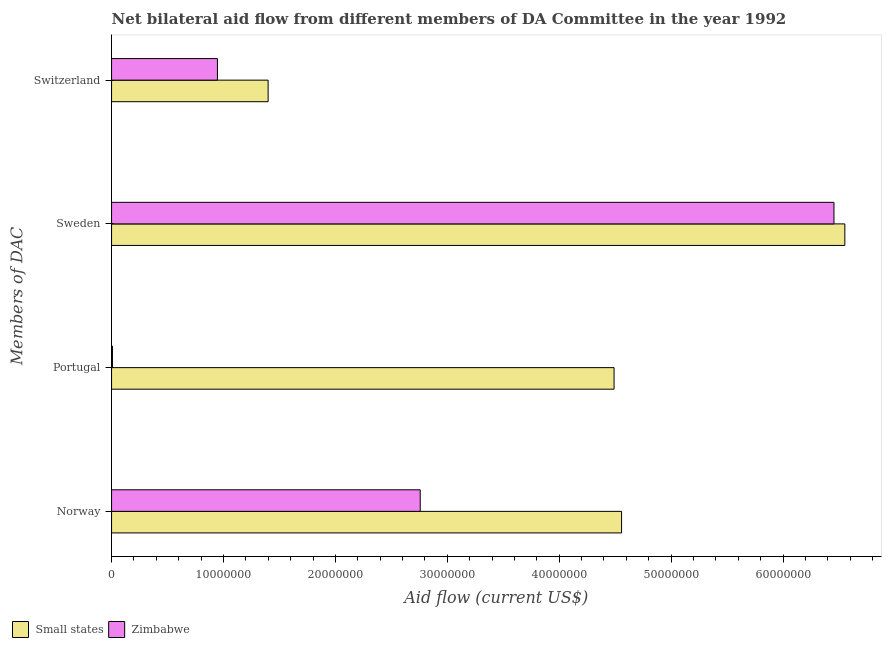How many groups of bars are there?
Ensure brevity in your answer.  4. Are the number of bars on each tick of the Y-axis equal?
Your answer should be very brief. Yes. How many bars are there on the 3rd tick from the bottom?
Offer a very short reply. 2. What is the amount of aid given by sweden in Small states?
Make the answer very short. 6.55e+07. Across all countries, what is the maximum amount of aid given by portugal?
Provide a short and direct response. 4.49e+07. Across all countries, what is the minimum amount of aid given by norway?
Give a very brief answer. 2.76e+07. In which country was the amount of aid given by switzerland maximum?
Offer a terse response. Small states. In which country was the amount of aid given by switzerland minimum?
Offer a very short reply. Zimbabwe. What is the total amount of aid given by sweden in the graph?
Your answer should be very brief. 1.30e+08. What is the difference between the amount of aid given by switzerland in Small states and that in Zimbabwe?
Provide a succinct answer. 4.53e+06. What is the difference between the amount of aid given by sweden in Zimbabwe and the amount of aid given by switzerland in Small states?
Offer a terse response. 5.06e+07. What is the average amount of aid given by sweden per country?
Provide a succinct answer. 6.50e+07. What is the difference between the amount of aid given by switzerland and amount of aid given by sweden in Zimbabwe?
Offer a very short reply. -5.51e+07. What is the ratio of the amount of aid given by switzerland in Zimbabwe to that in Small states?
Provide a succinct answer. 0.68. Is the amount of aid given by portugal in Zimbabwe less than that in Small states?
Your response must be concise. Yes. What is the difference between the highest and the second highest amount of aid given by sweden?
Ensure brevity in your answer.  9.70e+05. What is the difference between the highest and the lowest amount of aid given by norway?
Your response must be concise. 1.80e+07. What does the 2nd bar from the top in Norway represents?
Your answer should be compact. Small states. What does the 1st bar from the bottom in Portugal represents?
Your answer should be compact. Small states. Is it the case that in every country, the sum of the amount of aid given by norway and amount of aid given by portugal is greater than the amount of aid given by sweden?
Provide a short and direct response. No. Are all the bars in the graph horizontal?
Give a very brief answer. Yes. How many countries are there in the graph?
Your answer should be compact. 2. Are the values on the major ticks of X-axis written in scientific E-notation?
Provide a short and direct response. No. Does the graph contain any zero values?
Your response must be concise. No. Does the graph contain grids?
Make the answer very short. No. How many legend labels are there?
Ensure brevity in your answer.  2. How are the legend labels stacked?
Make the answer very short. Horizontal. What is the title of the graph?
Give a very brief answer. Net bilateral aid flow from different members of DA Committee in the year 1992. Does "India" appear as one of the legend labels in the graph?
Your answer should be very brief. No. What is the label or title of the Y-axis?
Your answer should be compact. Members of DAC. What is the Aid flow (current US$) in Small states in Norway?
Provide a short and direct response. 4.56e+07. What is the Aid flow (current US$) in Zimbabwe in Norway?
Provide a succinct answer. 2.76e+07. What is the Aid flow (current US$) in Small states in Portugal?
Provide a succinct answer. 4.49e+07. What is the Aid flow (current US$) of Small states in Sweden?
Your response must be concise. 6.55e+07. What is the Aid flow (current US$) in Zimbabwe in Sweden?
Provide a succinct answer. 6.46e+07. What is the Aid flow (current US$) in Small states in Switzerland?
Give a very brief answer. 1.40e+07. What is the Aid flow (current US$) in Zimbabwe in Switzerland?
Offer a terse response. 9.46e+06. Across all Members of DAC, what is the maximum Aid flow (current US$) of Small states?
Your response must be concise. 6.55e+07. Across all Members of DAC, what is the maximum Aid flow (current US$) in Zimbabwe?
Provide a short and direct response. 6.46e+07. Across all Members of DAC, what is the minimum Aid flow (current US$) in Small states?
Make the answer very short. 1.40e+07. Across all Members of DAC, what is the minimum Aid flow (current US$) in Zimbabwe?
Offer a very short reply. 8.00e+04. What is the total Aid flow (current US$) of Small states in the graph?
Give a very brief answer. 1.70e+08. What is the total Aid flow (current US$) in Zimbabwe in the graph?
Your response must be concise. 1.02e+08. What is the difference between the Aid flow (current US$) in Small states in Norway and that in Portugal?
Offer a very short reply. 6.70e+05. What is the difference between the Aid flow (current US$) of Zimbabwe in Norway and that in Portugal?
Your response must be concise. 2.75e+07. What is the difference between the Aid flow (current US$) in Small states in Norway and that in Sweden?
Your answer should be very brief. -2.00e+07. What is the difference between the Aid flow (current US$) in Zimbabwe in Norway and that in Sweden?
Offer a terse response. -3.70e+07. What is the difference between the Aid flow (current US$) in Small states in Norway and that in Switzerland?
Make the answer very short. 3.16e+07. What is the difference between the Aid flow (current US$) of Zimbabwe in Norway and that in Switzerland?
Give a very brief answer. 1.81e+07. What is the difference between the Aid flow (current US$) of Small states in Portugal and that in Sweden?
Offer a terse response. -2.06e+07. What is the difference between the Aid flow (current US$) in Zimbabwe in Portugal and that in Sweden?
Make the answer very short. -6.45e+07. What is the difference between the Aid flow (current US$) in Small states in Portugal and that in Switzerland?
Offer a terse response. 3.09e+07. What is the difference between the Aid flow (current US$) in Zimbabwe in Portugal and that in Switzerland?
Ensure brevity in your answer.  -9.38e+06. What is the difference between the Aid flow (current US$) of Small states in Sweden and that in Switzerland?
Give a very brief answer. 5.15e+07. What is the difference between the Aid flow (current US$) of Zimbabwe in Sweden and that in Switzerland?
Provide a succinct answer. 5.51e+07. What is the difference between the Aid flow (current US$) in Small states in Norway and the Aid flow (current US$) in Zimbabwe in Portugal?
Offer a terse response. 4.55e+07. What is the difference between the Aid flow (current US$) of Small states in Norway and the Aid flow (current US$) of Zimbabwe in Sweden?
Your answer should be compact. -1.90e+07. What is the difference between the Aid flow (current US$) in Small states in Norway and the Aid flow (current US$) in Zimbabwe in Switzerland?
Your answer should be compact. 3.61e+07. What is the difference between the Aid flow (current US$) in Small states in Portugal and the Aid flow (current US$) in Zimbabwe in Sweden?
Provide a succinct answer. -1.96e+07. What is the difference between the Aid flow (current US$) in Small states in Portugal and the Aid flow (current US$) in Zimbabwe in Switzerland?
Offer a very short reply. 3.54e+07. What is the difference between the Aid flow (current US$) in Small states in Sweden and the Aid flow (current US$) in Zimbabwe in Switzerland?
Offer a terse response. 5.61e+07. What is the average Aid flow (current US$) in Small states per Members of DAC?
Keep it short and to the point. 4.25e+07. What is the average Aid flow (current US$) of Zimbabwe per Members of DAC?
Your response must be concise. 2.54e+07. What is the difference between the Aid flow (current US$) of Small states and Aid flow (current US$) of Zimbabwe in Norway?
Provide a succinct answer. 1.80e+07. What is the difference between the Aid flow (current US$) in Small states and Aid flow (current US$) in Zimbabwe in Portugal?
Make the answer very short. 4.48e+07. What is the difference between the Aid flow (current US$) in Small states and Aid flow (current US$) in Zimbabwe in Sweden?
Provide a short and direct response. 9.70e+05. What is the difference between the Aid flow (current US$) of Small states and Aid flow (current US$) of Zimbabwe in Switzerland?
Provide a succinct answer. 4.53e+06. What is the ratio of the Aid flow (current US$) in Small states in Norway to that in Portugal?
Provide a succinct answer. 1.01. What is the ratio of the Aid flow (current US$) of Zimbabwe in Norway to that in Portugal?
Provide a short and direct response. 344.75. What is the ratio of the Aid flow (current US$) in Small states in Norway to that in Sweden?
Your response must be concise. 0.7. What is the ratio of the Aid flow (current US$) of Zimbabwe in Norway to that in Sweden?
Keep it short and to the point. 0.43. What is the ratio of the Aid flow (current US$) in Small states in Norway to that in Switzerland?
Ensure brevity in your answer.  3.26. What is the ratio of the Aid flow (current US$) of Zimbabwe in Norway to that in Switzerland?
Your answer should be very brief. 2.92. What is the ratio of the Aid flow (current US$) in Small states in Portugal to that in Sweden?
Ensure brevity in your answer.  0.69. What is the ratio of the Aid flow (current US$) of Zimbabwe in Portugal to that in Sweden?
Offer a very short reply. 0. What is the ratio of the Aid flow (current US$) of Small states in Portugal to that in Switzerland?
Provide a succinct answer. 3.21. What is the ratio of the Aid flow (current US$) of Zimbabwe in Portugal to that in Switzerland?
Provide a short and direct response. 0.01. What is the ratio of the Aid flow (current US$) of Small states in Sweden to that in Switzerland?
Provide a short and direct response. 4.68. What is the ratio of the Aid flow (current US$) in Zimbabwe in Sweden to that in Switzerland?
Provide a succinct answer. 6.82. What is the difference between the highest and the second highest Aid flow (current US$) of Small states?
Provide a short and direct response. 2.00e+07. What is the difference between the highest and the second highest Aid flow (current US$) in Zimbabwe?
Offer a very short reply. 3.70e+07. What is the difference between the highest and the lowest Aid flow (current US$) of Small states?
Your answer should be compact. 5.15e+07. What is the difference between the highest and the lowest Aid flow (current US$) of Zimbabwe?
Offer a terse response. 6.45e+07. 